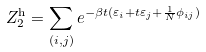<formula> <loc_0><loc_0><loc_500><loc_500>Z _ { 2 } ^ { \text {h} } = \sum _ { ( i , j ) } e ^ { - \beta t ( \varepsilon _ { i } + t \varepsilon _ { j } + \frac { 1 } { N } \phi _ { i j } ) }</formula> 